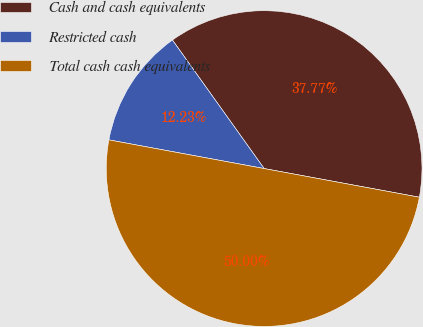Convert chart. <chart><loc_0><loc_0><loc_500><loc_500><pie_chart><fcel>Cash and cash equivalents<fcel>Restricted cash<fcel>Total cash cash equivalents<nl><fcel>37.77%<fcel>12.23%<fcel>50.0%<nl></chart> 